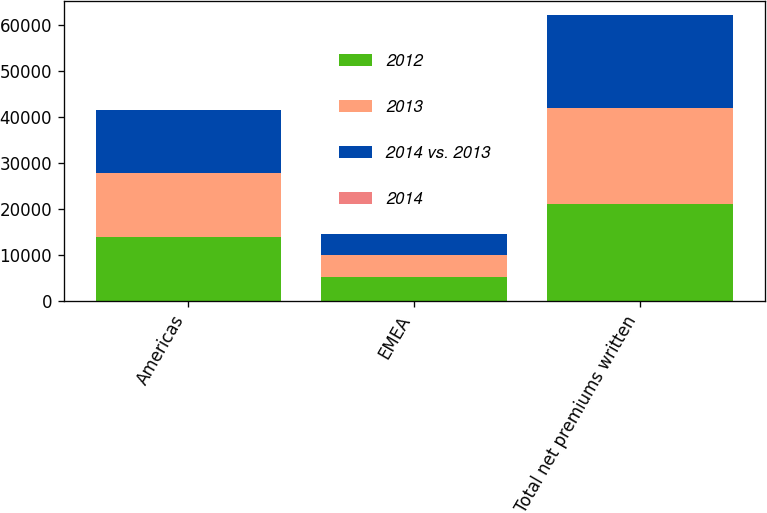Convert chart to OTSL. <chart><loc_0><loc_0><loc_500><loc_500><stacked_bar_chart><ecel><fcel>Americas<fcel>EMEA<fcel>Total net premiums written<nl><fcel>2012<fcel>13799<fcel>5192<fcel>21020<nl><fcel>2013<fcel>14050<fcel>4795<fcel>20880<nl><fcel>2014 vs. 2013<fcel>13718<fcel>4614<fcel>20348<nl><fcel>2014<fcel>2<fcel>8<fcel>1<nl></chart> 